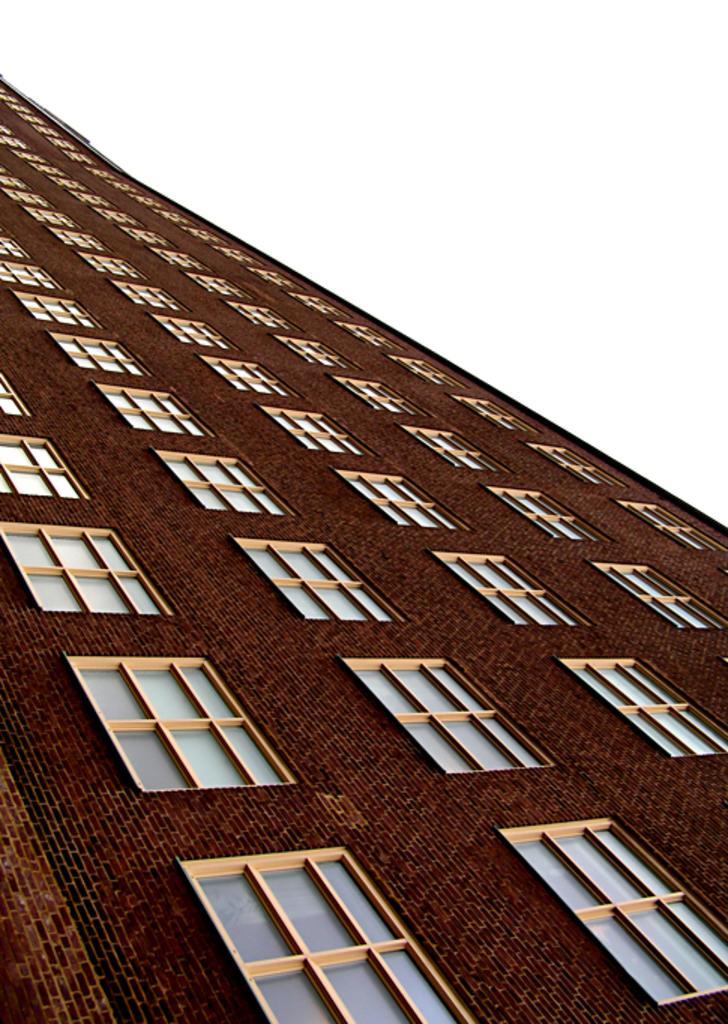Could you give a brief overview of what you see in this image? In this picture, we see a building in brown color. It is made up of bricks. It has glass windows. At the top of the picture, we see the sky. 